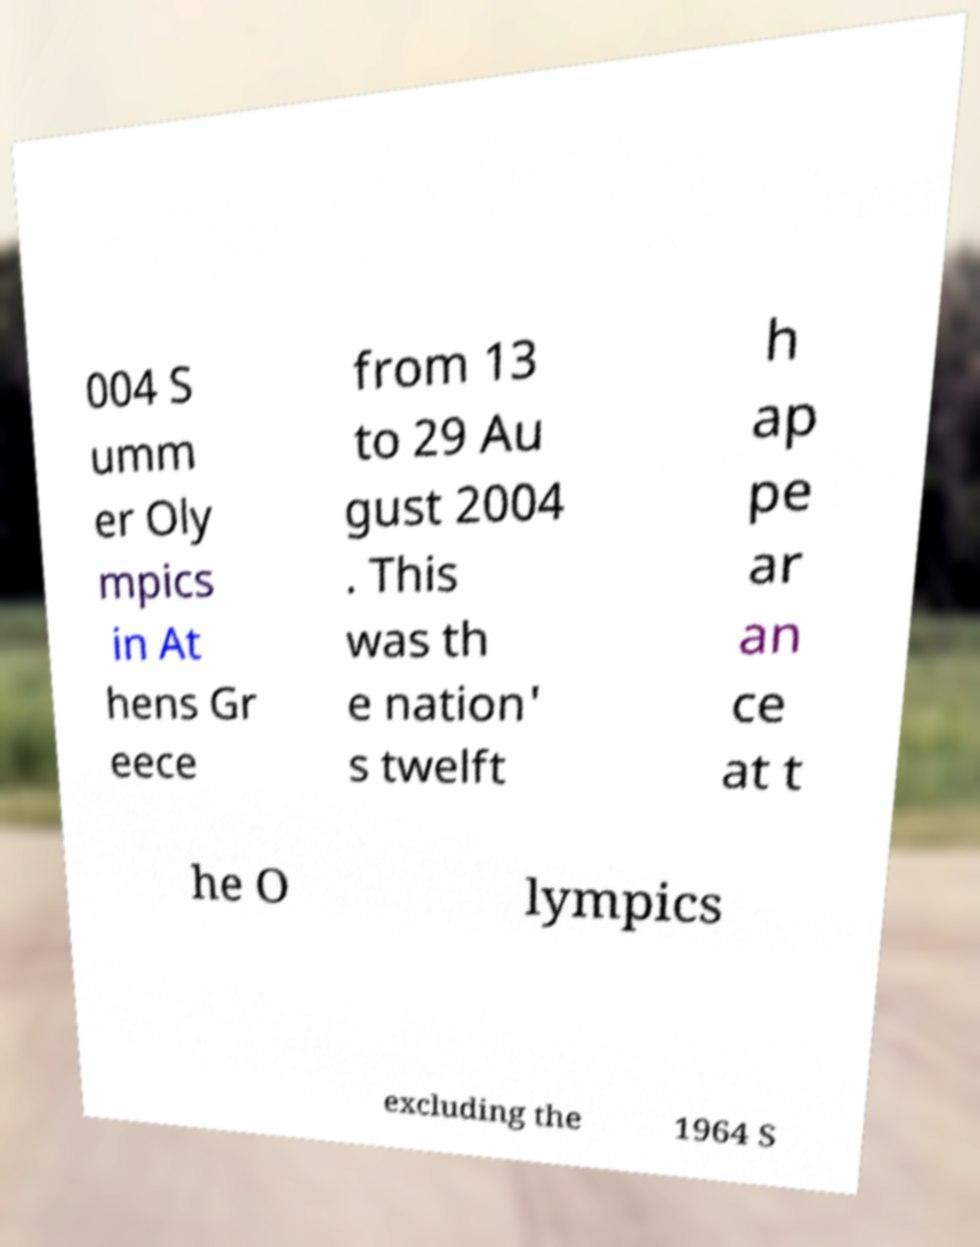What messages or text are displayed in this image? I need them in a readable, typed format. 004 S umm er Oly mpics in At hens Gr eece from 13 to 29 Au gust 2004 . This was th e nation' s twelft h ap pe ar an ce at t he O lympics excluding the 1964 S 